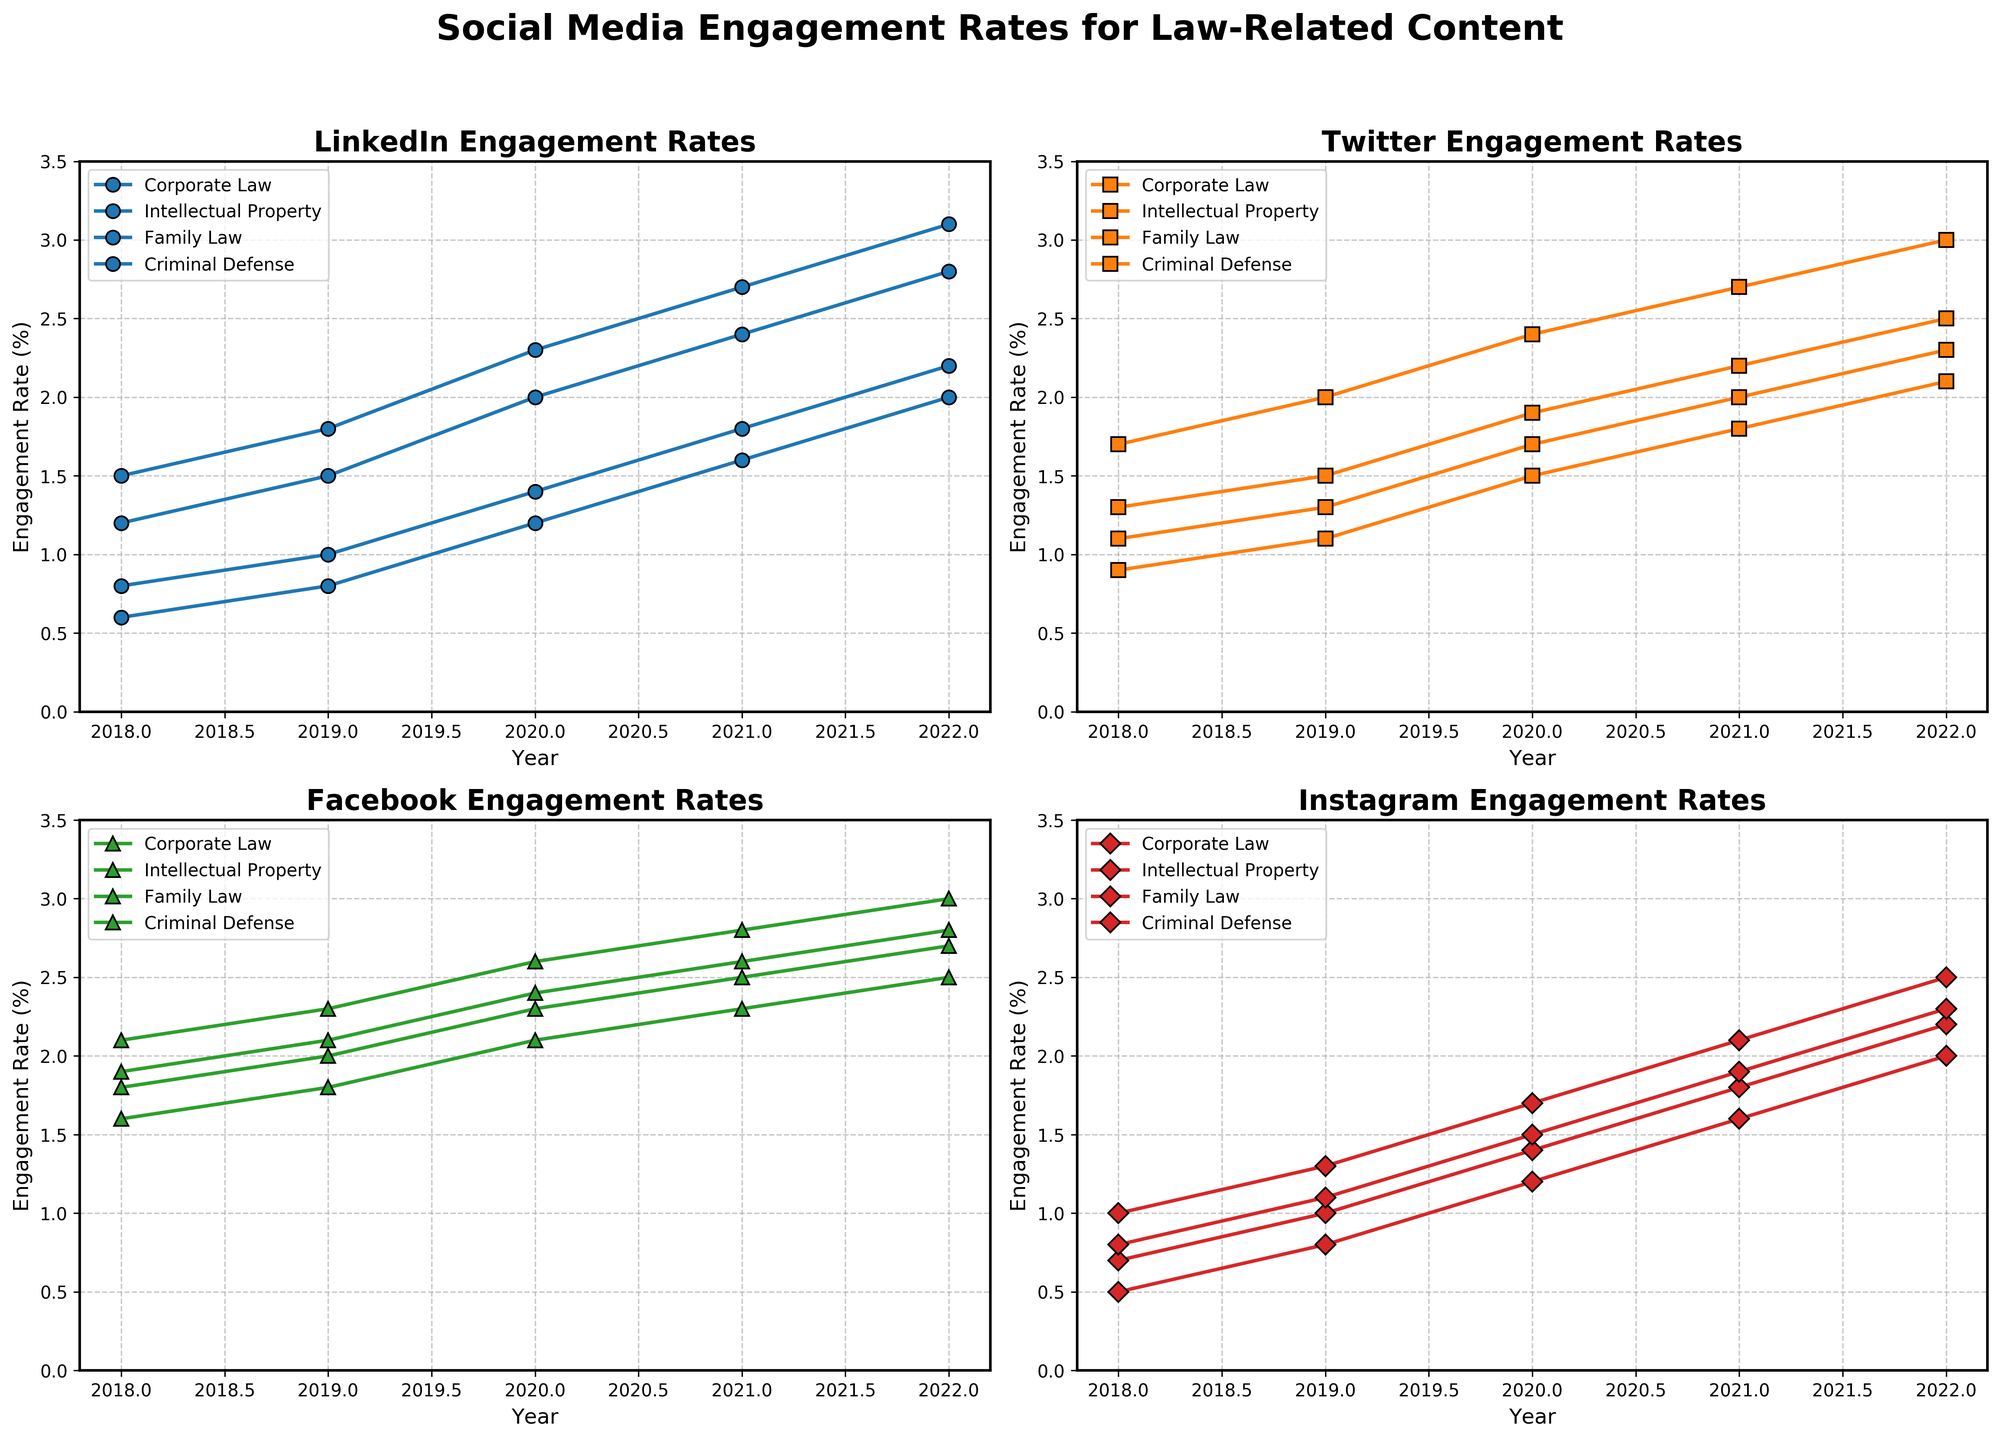What is the overall trend in engagement rates for Corporate Law on LinkedIn from 2018 to 2022? Observing the LinkedIn subplot, we see that the Corporate Law engagement rates increased gradually each year from 1.2% in 2018 to 2.8% in 2022. This indicates a positive overall trend.
Answer: Positive trend Which platform had the highest engagement rate for Family Law content in 2022? By comparing the engagement rates across all platform subplots for the year 2022, Facebook had the highest engagement rate for Family Law content at 3.0%.
Answer: Facebook What is the difference in engagement rates for Criminal Defense content between Twitter and Instagram in 2020? Looking at the 2020 data in the Twitter subplot, the engagement rate for Criminal Defense is 2.4%. In the Instagram subplot, it's 1.5%. The difference is 2.4% - 1.5% = 0.9%.
Answer: 0.9% Between 2019 and 2020, which platform saw the greatest increase in engagement rates for Intellectual Property content? We compare the engagement rates in 2019 and 2020 for Intellectual Property content in each subplot. LinkedIn increased from 1.8% to 2.3%, Twitter from 1.3% to 1.7%, Facebook from 1.8% to 2.1%, and Instagram from 1.0% to 1.4%. LinkedIn had the greatest increase of 0.5%.
Answer: LinkedIn What is the average engagement rate for Corporate Law content on Facebook over all years shown in the figure? The Facebook engagement rates for Corporate Law are 1.8% (2018), 2.0% (2019), 2.3% (2020), 2.5% (2021), and 2.7% (2022). The average is (1.8 + 2.0 + 2.3 + 2.5 + 2.7) / 5 = 11.3 / 5 = 2.26%.
Answer: 2.26% How did the engagement rate for Family Law content on Instagram change from 2018 to 2022? Observing the Instagram subplot for Family Law content, the engagement rate increased from 1.0% in 2018 to 2.5% in 2022. Thus, it has risen over the years.
Answer: Increased Which platform had a consistent increase in engagement rates for all law-related categories from 2018 to 2022? By examining each subplot, LinkedIn shows a consistent increase in engagement rates for Corporate Law, Intellectual Property, Family Law, and Criminal Defense from 2018 to 2022.
Answer: LinkedIn In 2021, which law-related category had the lowest engagement rate across all platforms? Checking the 2021 year in each subplot, Family Law on Instagram had the lowest engagement rate at 2.1%.
Answer: Family Law on Instagram Compare the engagement rates for Corporate Law and Family Law on Twitter in 2021. Which one had a higher rate and by how much? The Twitter subplot shows that in 2021, Corporate Law's engagement rate was 1.8%, while Family Law's was 2.2%. Family Law had a higher rate by 2.2% - 1.8% = 0.4%.
Answer: Family Law by 0.4% 